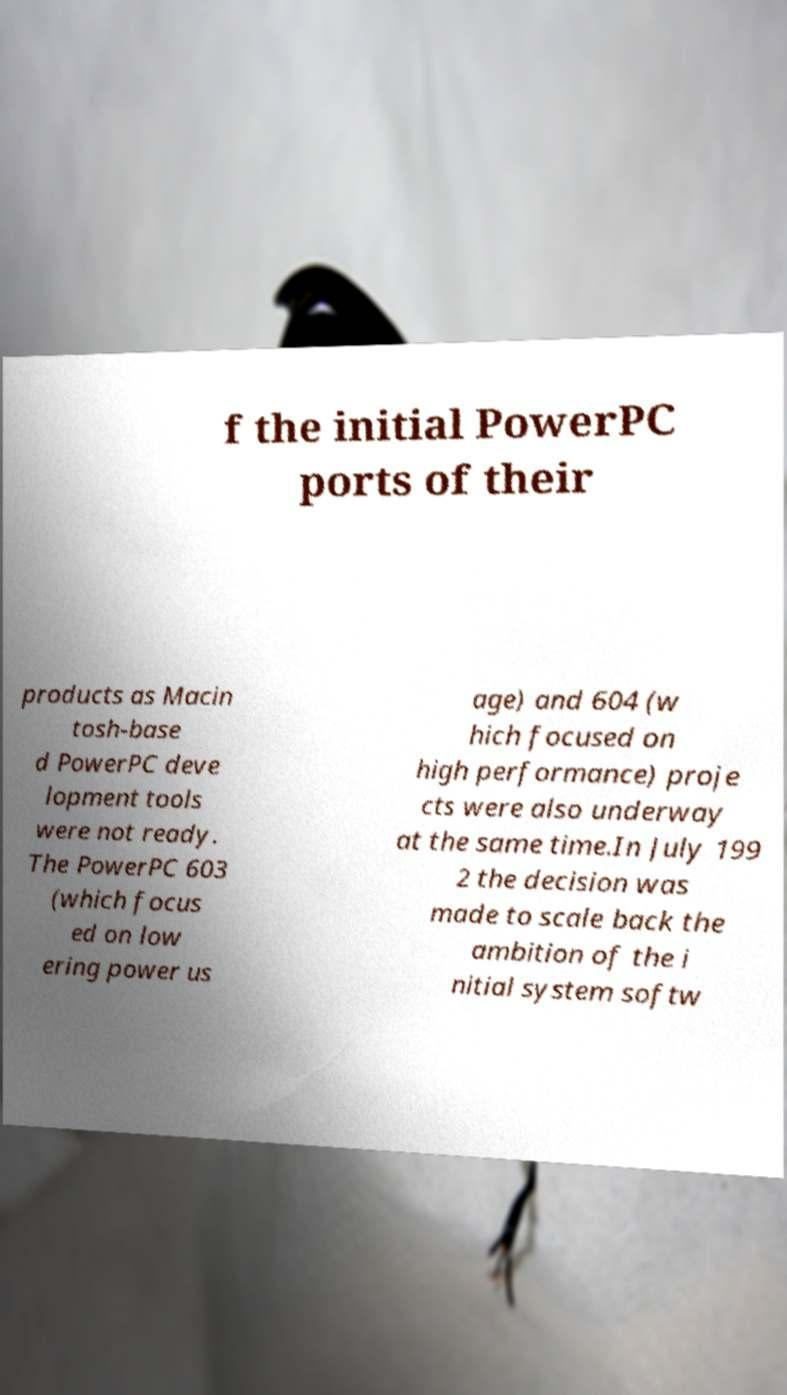Please identify and transcribe the text found in this image. f the initial PowerPC ports of their products as Macin tosh-base d PowerPC deve lopment tools were not ready. The PowerPC 603 (which focus ed on low ering power us age) and 604 (w hich focused on high performance) proje cts were also underway at the same time.In July 199 2 the decision was made to scale back the ambition of the i nitial system softw 